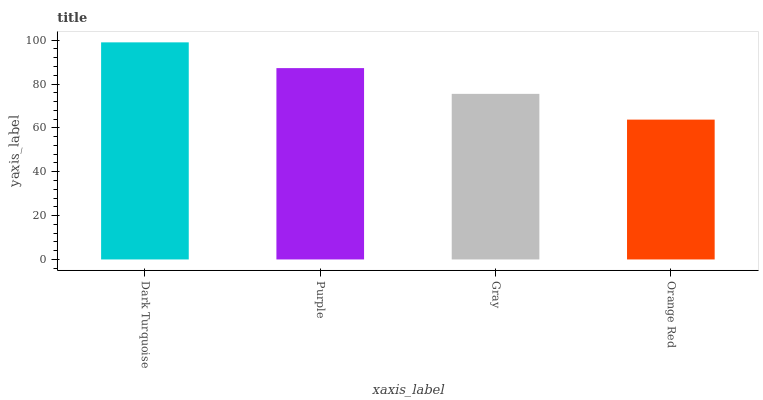Is Orange Red the minimum?
Answer yes or no. Yes. Is Dark Turquoise the maximum?
Answer yes or no. Yes. Is Purple the minimum?
Answer yes or no. No. Is Purple the maximum?
Answer yes or no. No. Is Dark Turquoise greater than Purple?
Answer yes or no. Yes. Is Purple less than Dark Turquoise?
Answer yes or no. Yes. Is Purple greater than Dark Turquoise?
Answer yes or no. No. Is Dark Turquoise less than Purple?
Answer yes or no. No. Is Purple the high median?
Answer yes or no. Yes. Is Gray the low median?
Answer yes or no. Yes. Is Gray the high median?
Answer yes or no. No. Is Orange Red the low median?
Answer yes or no. No. 